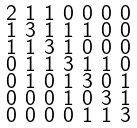Convert formula to latex. <formula><loc_0><loc_0><loc_500><loc_500>\begin{smallmatrix} 2 & 1 & 1 & 0 & 0 & 0 & 0 \\ 1 & 3 & 1 & 1 & 1 & 0 & 0 \\ 1 & 1 & 3 & 1 & 0 & 0 & 0 \\ 0 & 1 & 1 & 3 & 1 & 1 & 0 \\ 0 & 1 & 0 & 1 & 3 & 0 & 1 \\ 0 & 0 & 0 & 1 & 0 & 3 & 1 \\ 0 & 0 & 0 & 0 & 1 & 1 & 3 \end{smallmatrix}</formula> 